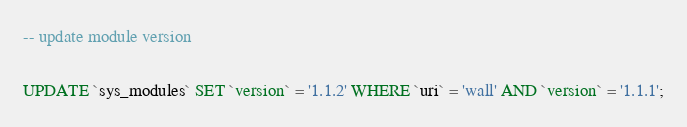<code> <loc_0><loc_0><loc_500><loc_500><_SQL_>

-- update module version

UPDATE `sys_modules` SET `version` = '1.1.2' WHERE `uri` = 'wall' AND `version` = '1.1.1';

</code> 